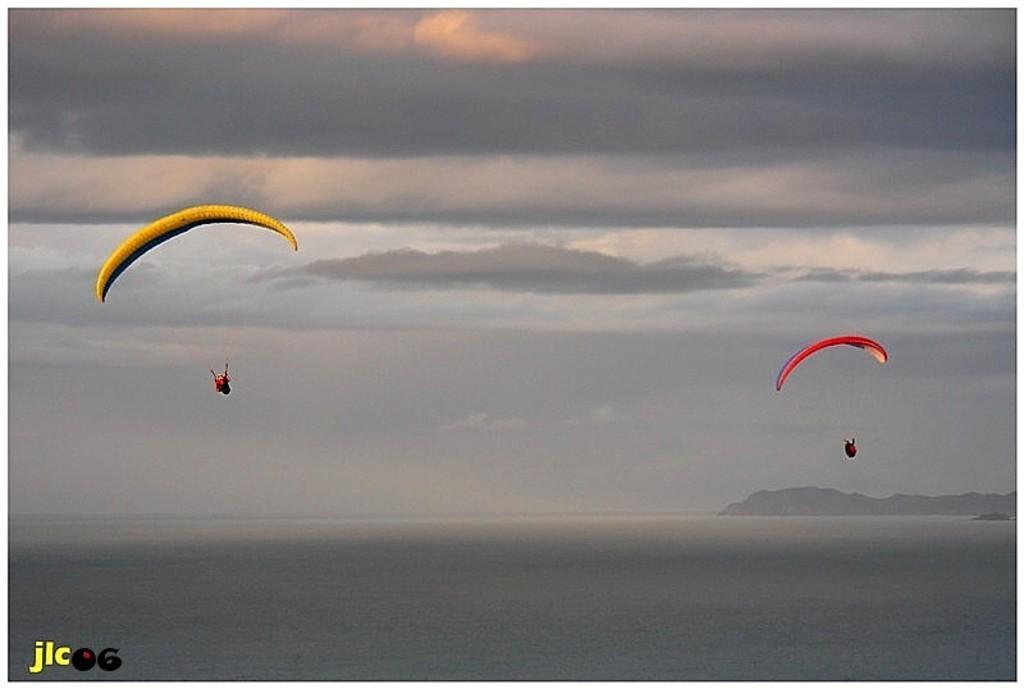How would you summarize this image in a sentence or two? In this image there are two persons parachuting with the parachute in the sky , and there is water, there are hills and a watermark on the image. 